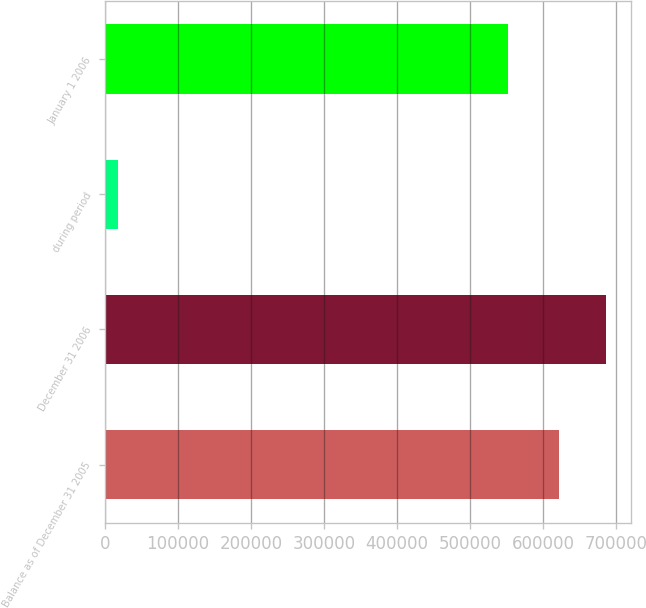<chart> <loc_0><loc_0><loc_500><loc_500><bar_chart><fcel>Balance as of December 31 2005<fcel>December 31 2006<fcel>during period<fcel>January 1 2006<nl><fcel>622094<fcel>686593<fcel>17324<fcel>552003<nl></chart> 